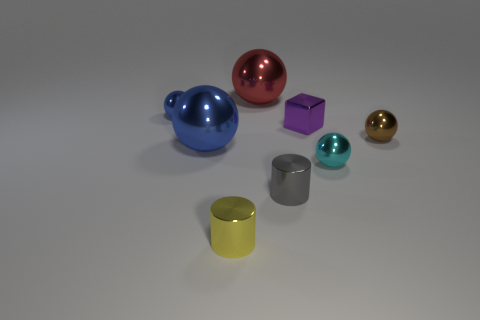Subtract 1 spheres. How many spheres are left? 4 Subtract all brown metal spheres. How many spheres are left? 4 Subtract all purple balls. Subtract all blue cylinders. How many balls are left? 5 Add 2 tiny cyan cylinders. How many objects exist? 10 Subtract all balls. How many objects are left? 3 Add 2 large blue spheres. How many large blue spheres exist? 3 Subtract 0 brown blocks. How many objects are left? 8 Subtract all tiny purple metal cylinders. Subtract all small yellow metallic objects. How many objects are left? 7 Add 7 large blue things. How many large blue things are left? 8 